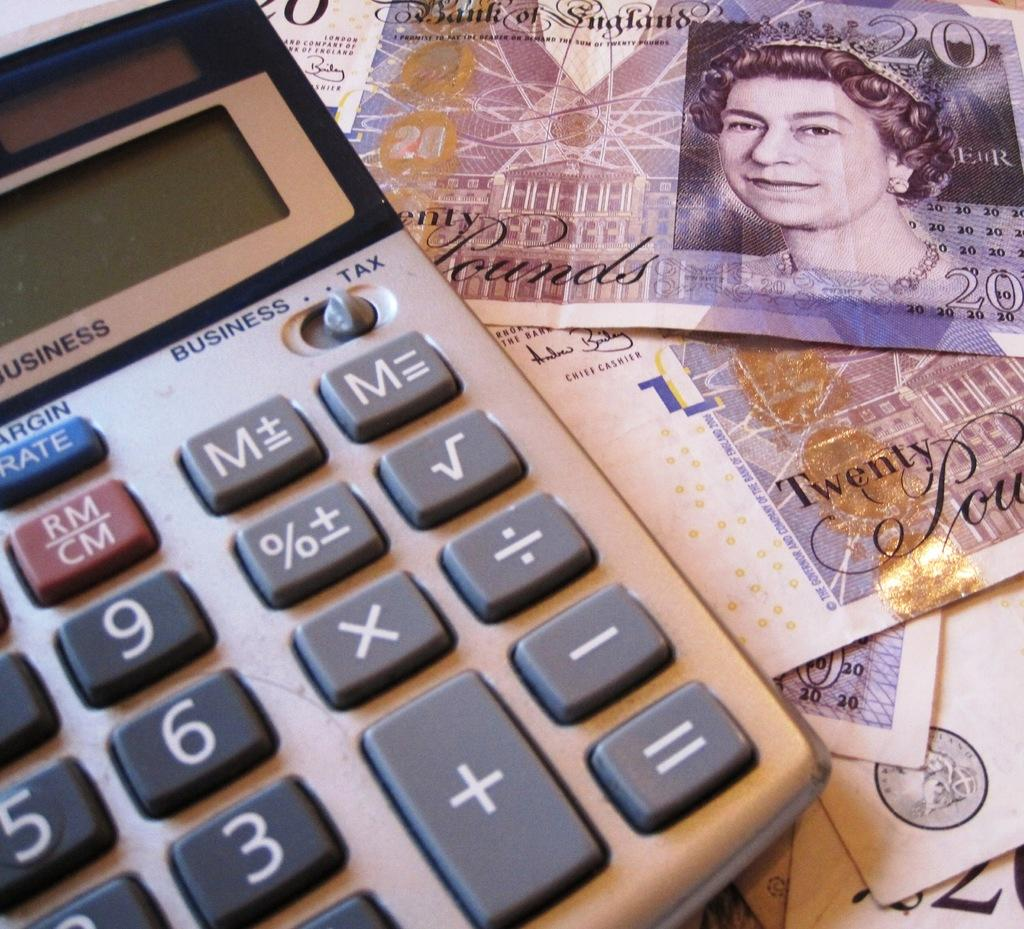Provide a one-sentence caption for the provided image. Underneath the calculator was a twenty pound bill. 